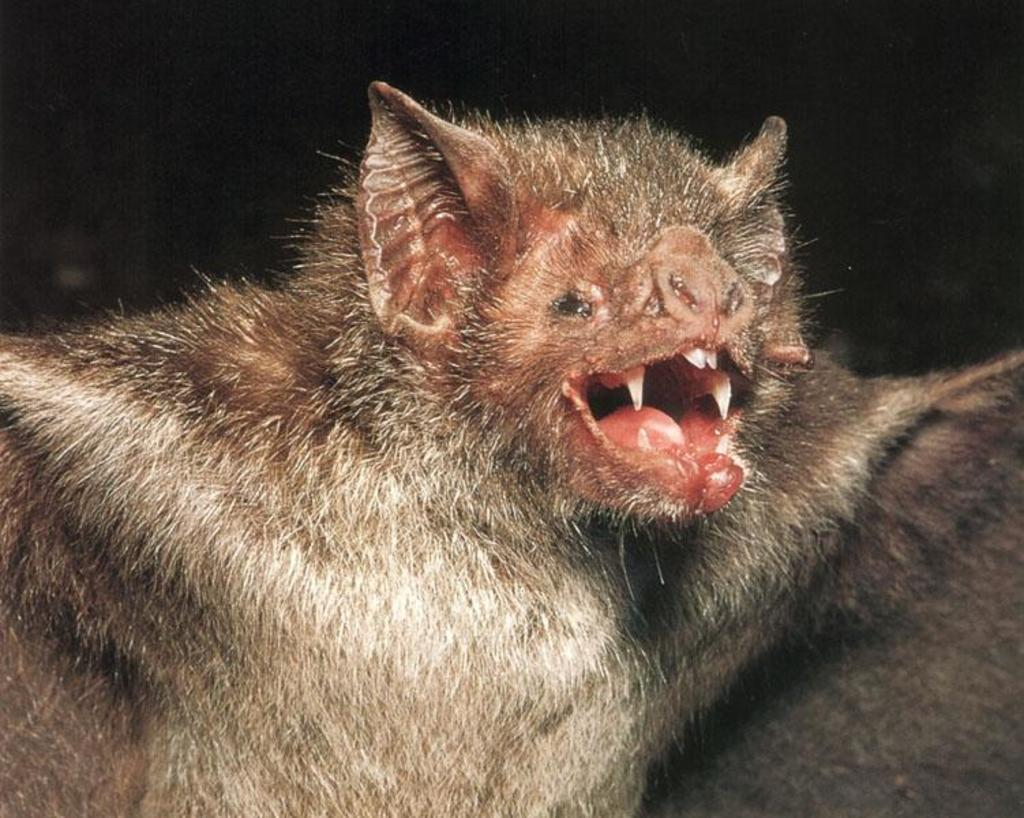What animal is present in the image? There is a bat in the image. What is the bat doing in the image? The bat has its mouth open. What page is the bat turning in the image? There is no page present in the image, as it features a bat with its mouth open. 